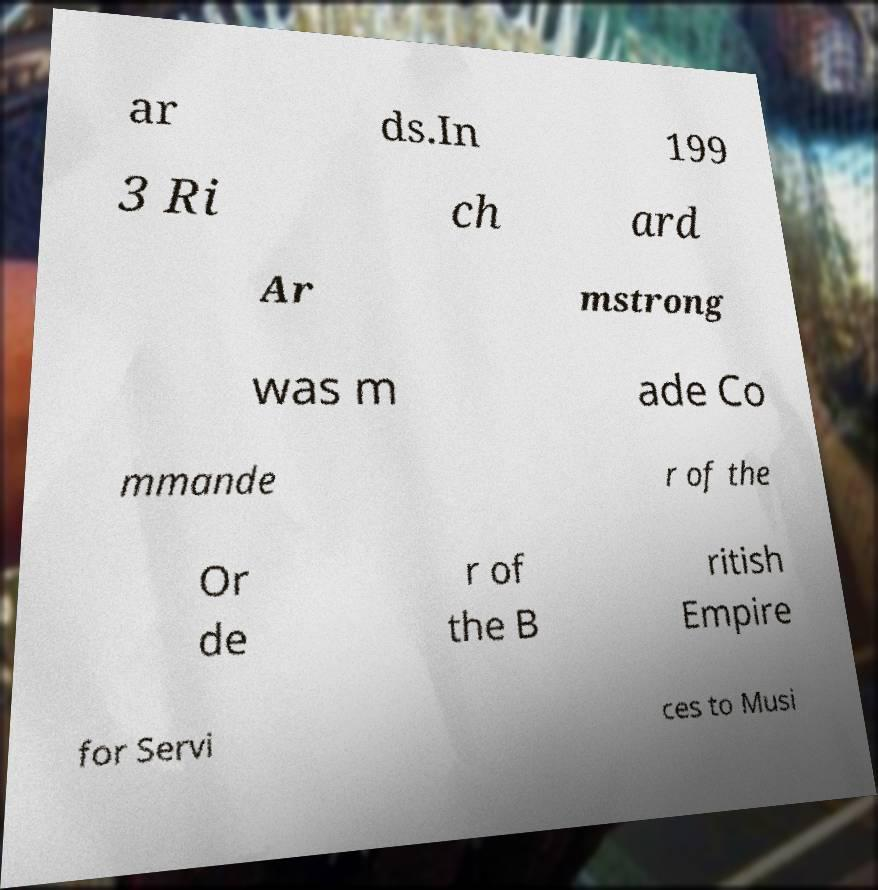Can you read and provide the text displayed in the image?This photo seems to have some interesting text. Can you extract and type it out for me? ar ds.In 199 3 Ri ch ard Ar mstrong was m ade Co mmande r of the Or de r of the B ritish Empire for Servi ces to Musi 